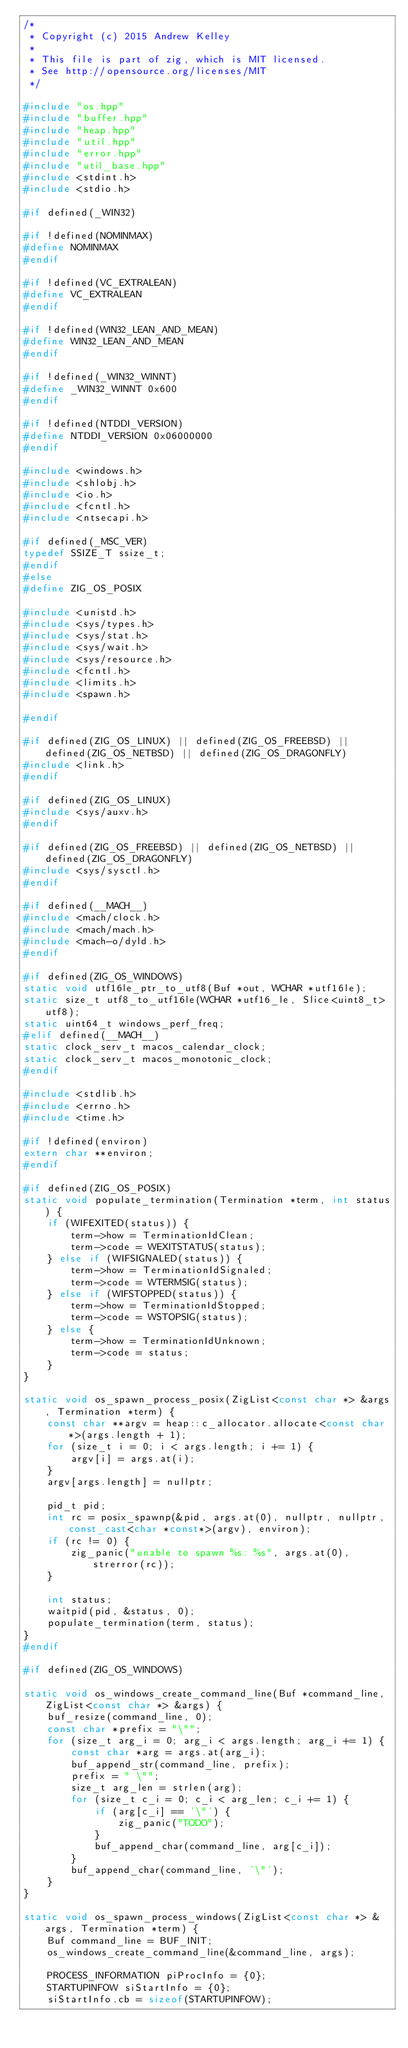Convert code to text. <code><loc_0><loc_0><loc_500><loc_500><_C++_>/*
 * Copyright (c) 2015 Andrew Kelley
 *
 * This file is part of zig, which is MIT licensed.
 * See http://opensource.org/licenses/MIT
 */

#include "os.hpp"
#include "buffer.hpp"
#include "heap.hpp"
#include "util.hpp"
#include "error.hpp"
#include "util_base.hpp"
#include <stdint.h>
#include <stdio.h>

#if defined(_WIN32)

#if !defined(NOMINMAX)
#define NOMINMAX
#endif

#if !defined(VC_EXTRALEAN)
#define VC_EXTRALEAN
#endif

#if !defined(WIN32_LEAN_AND_MEAN)
#define WIN32_LEAN_AND_MEAN
#endif

#if !defined(_WIN32_WINNT)
#define _WIN32_WINNT 0x600
#endif

#if !defined(NTDDI_VERSION)
#define NTDDI_VERSION 0x06000000
#endif

#include <windows.h>
#include <shlobj.h>
#include <io.h>
#include <fcntl.h>
#include <ntsecapi.h>

#if defined(_MSC_VER)
typedef SSIZE_T ssize_t;
#endif
#else
#define ZIG_OS_POSIX

#include <unistd.h>
#include <sys/types.h>
#include <sys/stat.h>
#include <sys/wait.h>
#include <sys/resource.h>
#include <fcntl.h>
#include <limits.h>
#include <spawn.h>

#endif

#if defined(ZIG_OS_LINUX) || defined(ZIG_OS_FREEBSD) || defined(ZIG_OS_NETBSD) || defined(ZIG_OS_DRAGONFLY)
#include <link.h>
#endif

#if defined(ZIG_OS_LINUX)
#include <sys/auxv.h>
#endif

#if defined(ZIG_OS_FREEBSD) || defined(ZIG_OS_NETBSD) || defined(ZIG_OS_DRAGONFLY)
#include <sys/sysctl.h>
#endif

#if defined(__MACH__)
#include <mach/clock.h>
#include <mach/mach.h>
#include <mach-o/dyld.h>
#endif

#if defined(ZIG_OS_WINDOWS)
static void utf16le_ptr_to_utf8(Buf *out, WCHAR *utf16le);
static size_t utf8_to_utf16le(WCHAR *utf16_le, Slice<uint8_t> utf8);
static uint64_t windows_perf_freq;
#elif defined(__MACH__)
static clock_serv_t macos_calendar_clock;
static clock_serv_t macos_monotonic_clock;
#endif

#include <stdlib.h>
#include <errno.h>
#include <time.h>

#if !defined(environ)
extern char **environ;
#endif

#if defined(ZIG_OS_POSIX)
static void populate_termination(Termination *term, int status) {
    if (WIFEXITED(status)) {
        term->how = TerminationIdClean;
        term->code = WEXITSTATUS(status);
    } else if (WIFSIGNALED(status)) {
        term->how = TerminationIdSignaled;
        term->code = WTERMSIG(status);
    } else if (WIFSTOPPED(status)) {
        term->how = TerminationIdStopped;
        term->code = WSTOPSIG(status);
    } else {
        term->how = TerminationIdUnknown;
        term->code = status;
    }
}

static void os_spawn_process_posix(ZigList<const char *> &args, Termination *term) {
    const char **argv = heap::c_allocator.allocate<const char *>(args.length + 1);
    for (size_t i = 0; i < args.length; i += 1) {
        argv[i] = args.at(i);
    }
    argv[args.length] = nullptr;

    pid_t pid;
    int rc = posix_spawnp(&pid, args.at(0), nullptr, nullptr, const_cast<char *const*>(argv), environ);
    if (rc != 0) {
        zig_panic("unable to spawn %s: %s", args.at(0), strerror(rc));
    }

    int status;
    waitpid(pid, &status, 0);
    populate_termination(term, status);
}
#endif

#if defined(ZIG_OS_WINDOWS)

static void os_windows_create_command_line(Buf *command_line, ZigList<const char *> &args) {
    buf_resize(command_line, 0);
    const char *prefix = "\"";
    for (size_t arg_i = 0; arg_i < args.length; arg_i += 1) {
        const char *arg = args.at(arg_i);
        buf_append_str(command_line, prefix);
        prefix = " \"";
        size_t arg_len = strlen(arg);
        for (size_t c_i = 0; c_i < arg_len; c_i += 1) {
            if (arg[c_i] == '\"') {
                zig_panic("TODO");
            }
            buf_append_char(command_line, arg[c_i]);
        }
        buf_append_char(command_line, '\"');
    }
}

static void os_spawn_process_windows(ZigList<const char *> &args, Termination *term) {
    Buf command_line = BUF_INIT;
    os_windows_create_command_line(&command_line, args);

    PROCESS_INFORMATION piProcInfo = {0};
    STARTUPINFOW siStartInfo = {0};
    siStartInfo.cb = sizeof(STARTUPINFOW);
</code> 